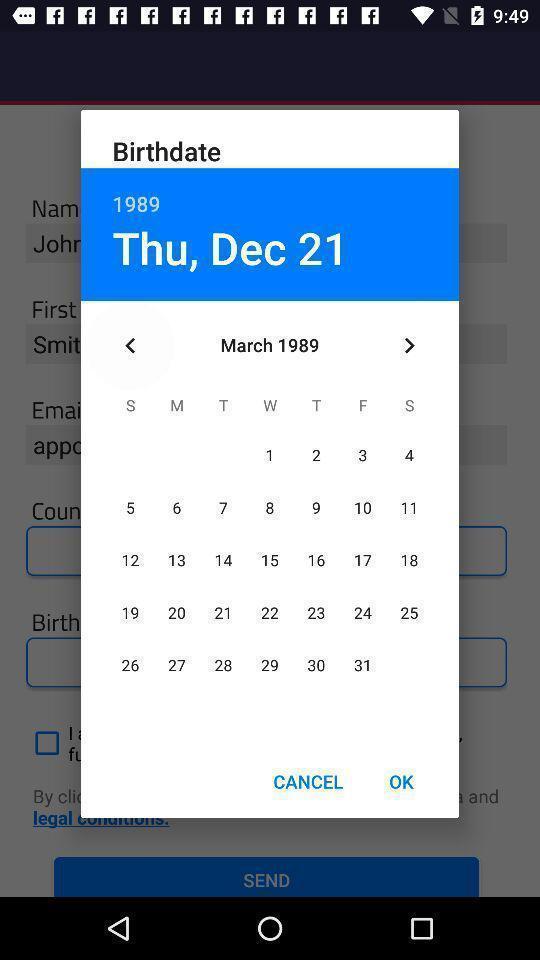Describe the key features of this screenshot. Pop-up showing to select birthdate. 